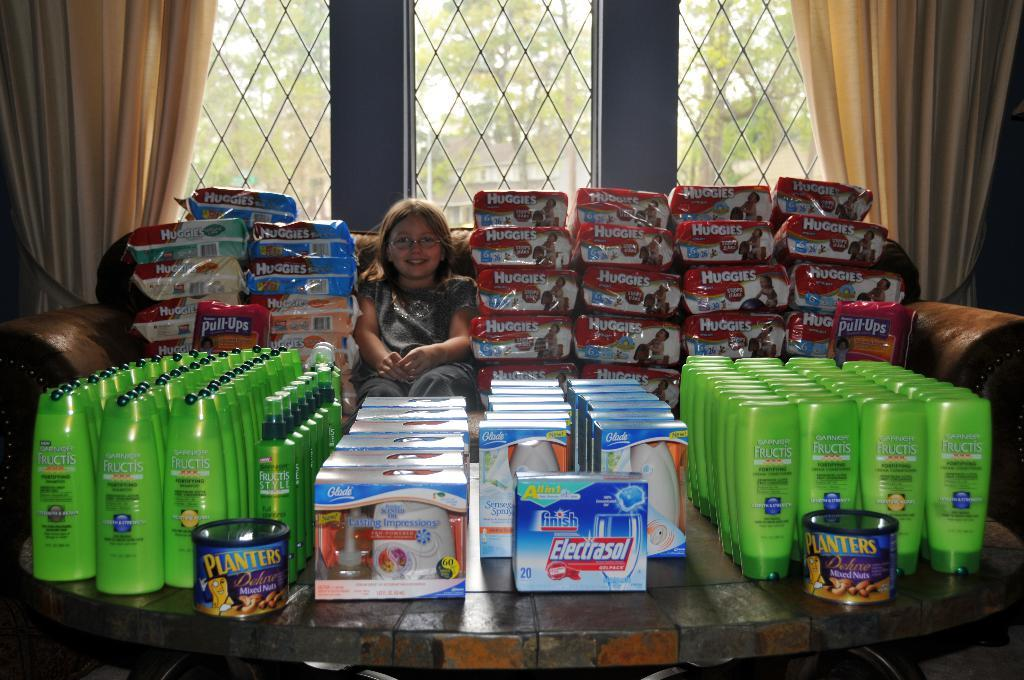<image>
Summarize the visual content of the image. a girl posing next to huggies diapers and nuts 